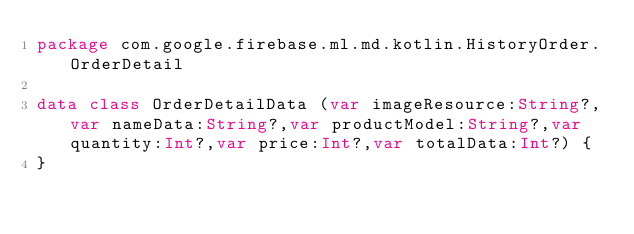<code> <loc_0><loc_0><loc_500><loc_500><_Kotlin_>package com.google.firebase.ml.md.kotlin.HistoryOrder.OrderDetail

data class OrderDetailData (var imageResource:String?,var nameData:String?,var productModel:String?,var quantity:Int?,var price:Int?,var totalData:Int?) {
}</code> 